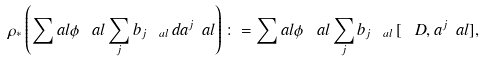Convert formula to latex. <formula><loc_0><loc_0><loc_500><loc_500>\rho _ { * } \left ( \sum _ { \ } a l \phi _ { \ } a l \sum _ { j } b _ { j \ a l } \, d a ^ { j } _ { \ } a l \right ) \colon = \sum _ { \ } a l \phi _ { \ } a l \sum _ { j } b _ { j \ a l } \, [ \ D , a ^ { j } _ { \ } a l ] ,</formula> 